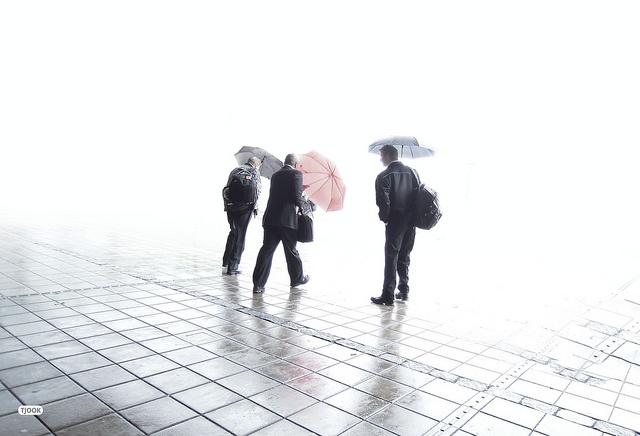Describe the objects in this image and their specific colors. I can see people in white, black, and gray tones, people in white, black, gray, and darkgray tones, people in white, black, gray, and darkgray tones, umbrella in white, lightgray, and pink tones, and backpack in white, black, gray, and lightgray tones in this image. 